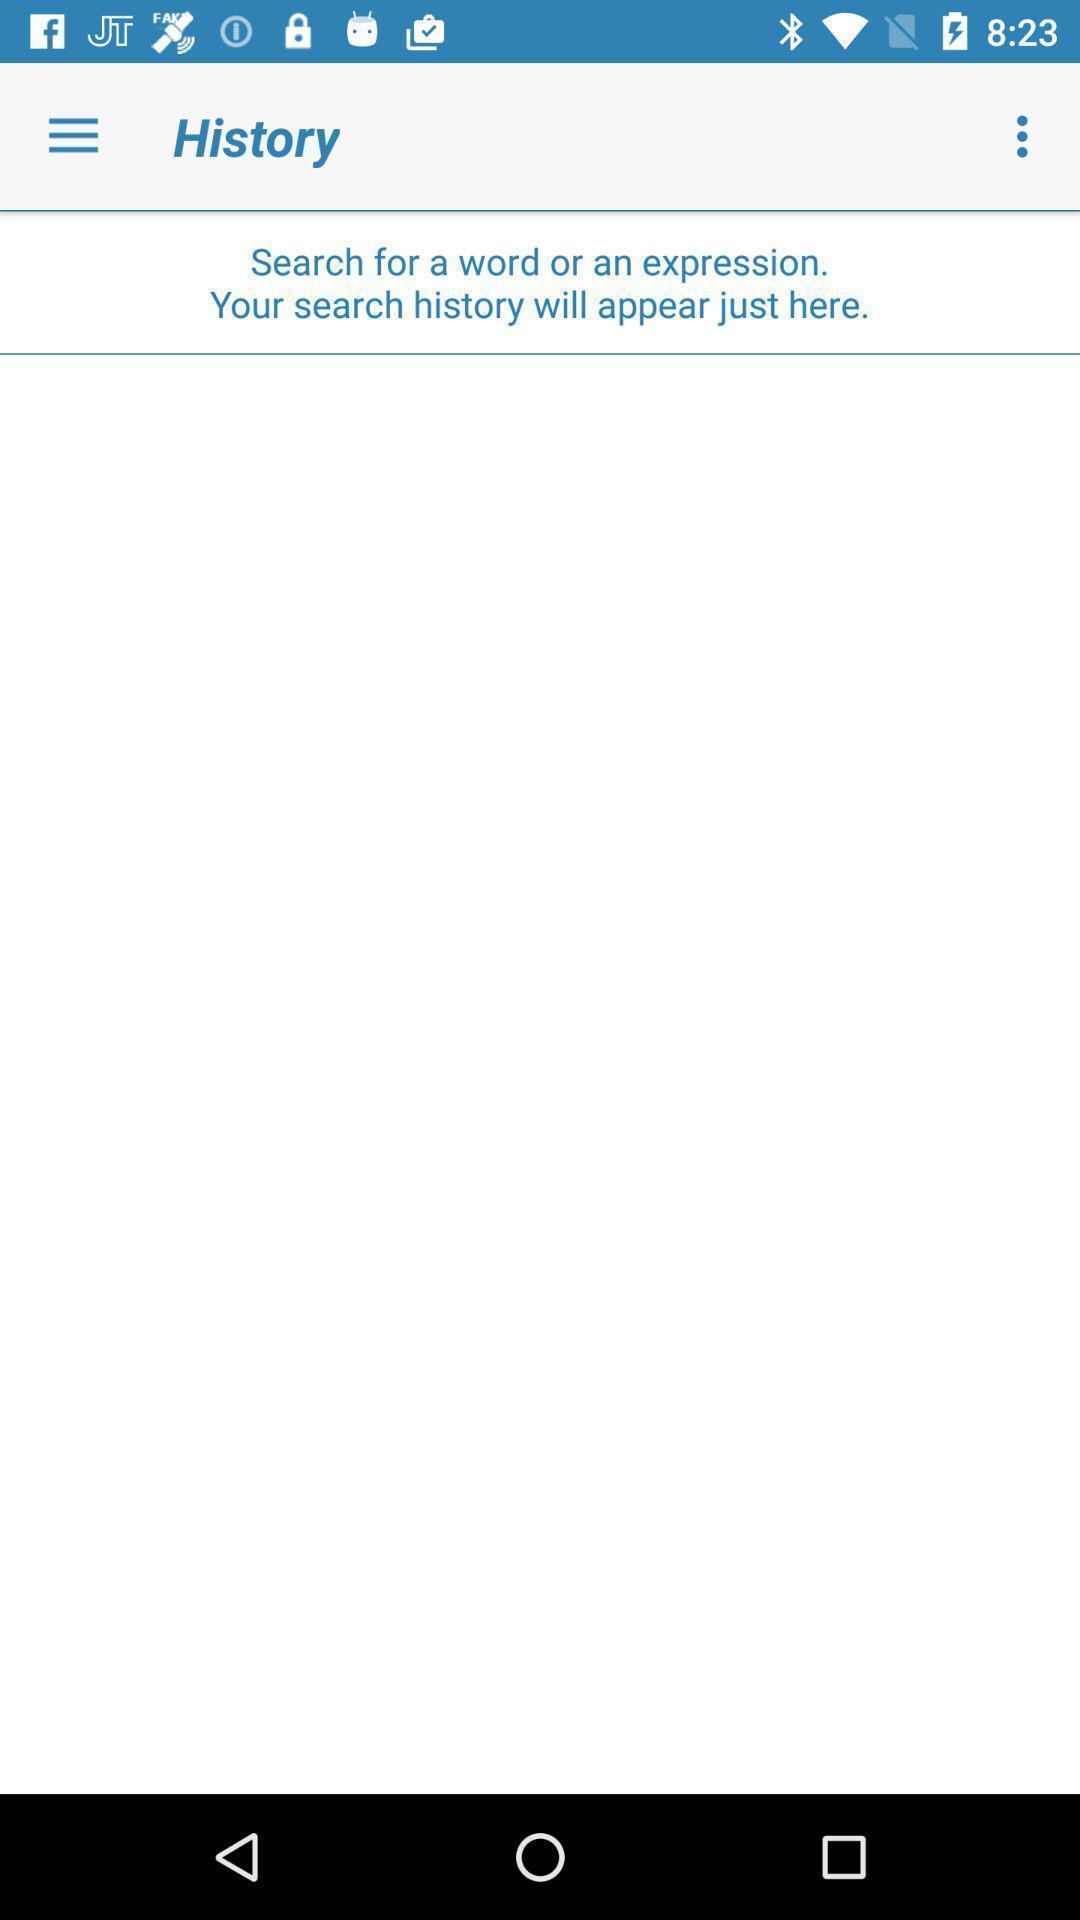Tell me what you see in this picture. Screen displaying the history page. 